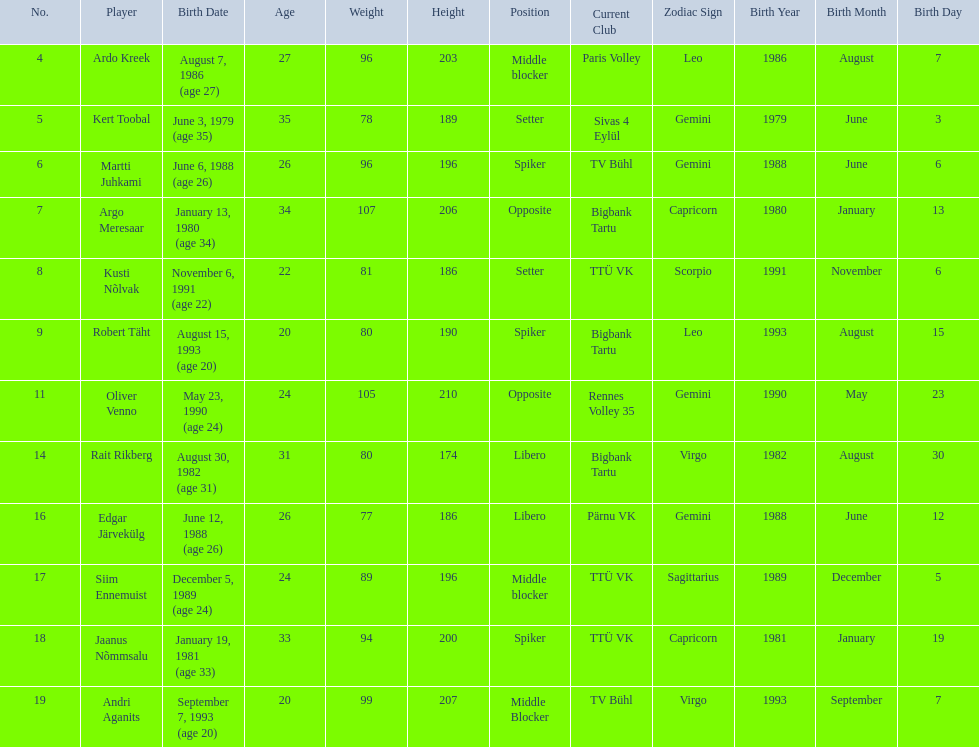What are the heights in cm of the men on the team? 203, 189, 196, 206, 186, 190, 210, 174, 186, 196, 200, 207. What is the tallest height of a team member? 210. Which player stands at 210? Oliver Venno. 